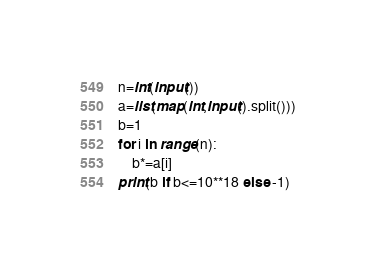<code> <loc_0><loc_0><loc_500><loc_500><_Python_>n=int(input())
a=list(map(int,input().split()))
b=1
for i in range(n):
    b*=a[i]
print(b if b<=10**18 else -1)</code> 